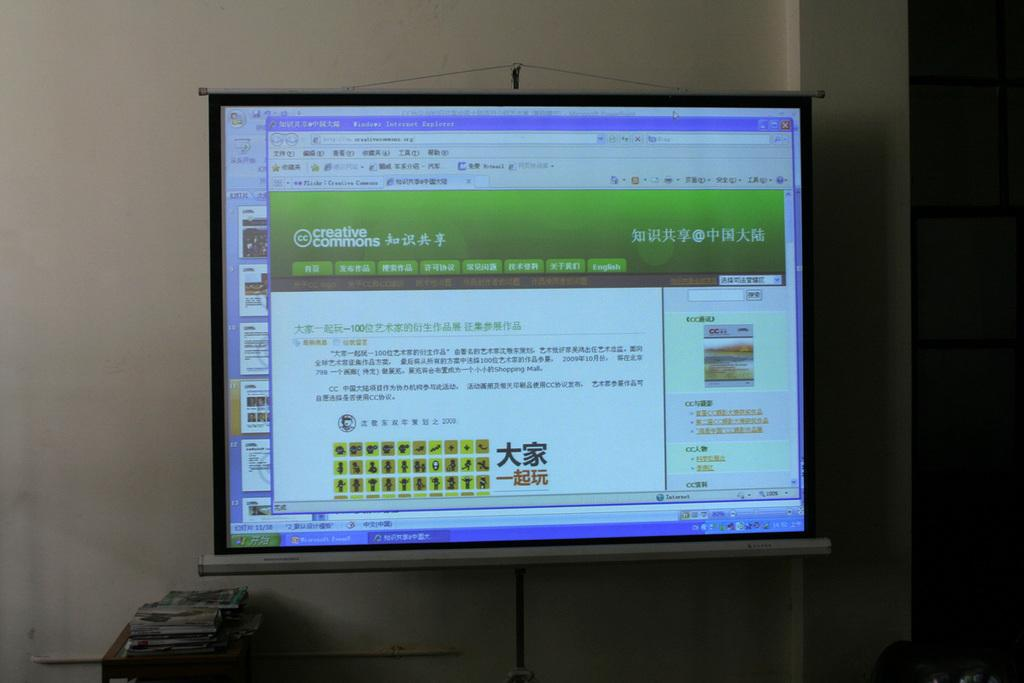Provide a one-sentence caption for the provided image. Creative Commons web page, not translated, pulled up on a computer monitor. 